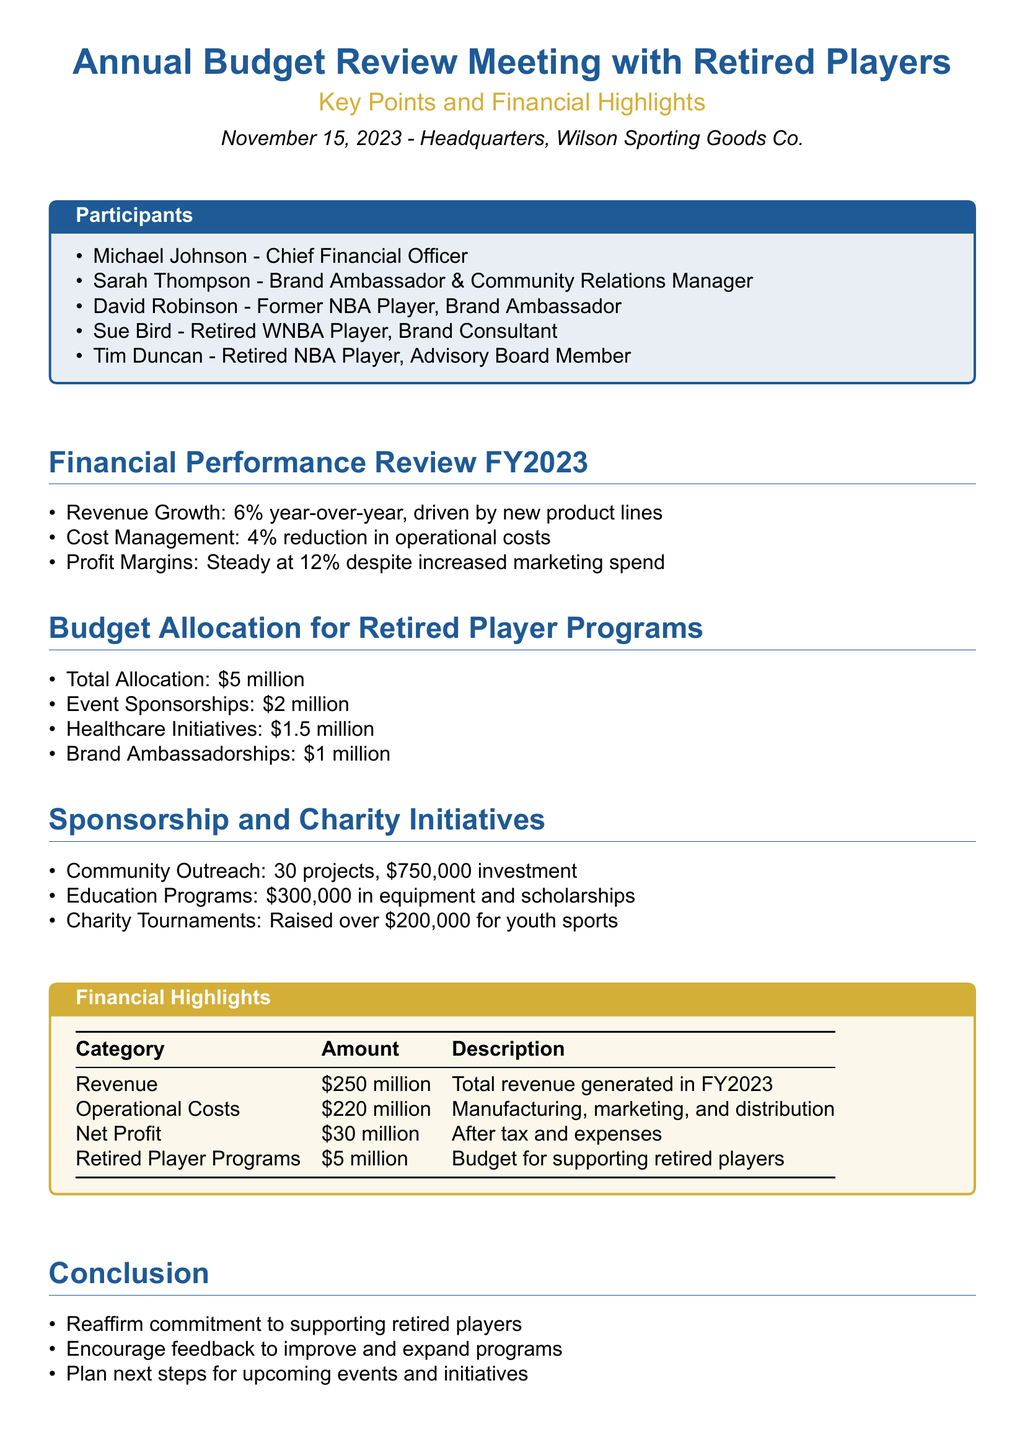What was the revenue growth percentage for FY2023? The revenue growth percentage for FY2023 is mentioned as 6% year-over-year.
Answer: 6% What is the total budget allocation for retired player programs? The total budget allocation for retired player programs is specified in the document as $5 million.
Answer: $5 million Who is the Chief Financial Officer listed in the participants? The document lists Michael Johnson as the Chief Financial Officer.
Answer: Michael Johnson How much was raised through charity tournaments? The document states that over $200,000 was raised for youth sports through charity tournaments.
Answer: Over $200,000 What is the operational cost amount in FY2023? The operational costs for FY2023 are provided as $220 million in the financial highlights section.
Answer: $220 million How much funding is allocated for healthcare initiatives? The funding allocated for healthcare initiatives is stated as $1.5 million in the budget allocation section.
Answer: $1.5 million What was the net profit after tax and expenses? The document indicates that the net profit after tax and expenses is $30 million.
Answer: $30 million What is the purpose of the community outreach projects? The document outlines that community outreach projects aim to invest in local initiatives, totaling a $750,000 investment.
Answer: $750,000 investment How many participants are listed in the document? The document lists five participants in the annual budget review meeting.
Answer: Five participants 